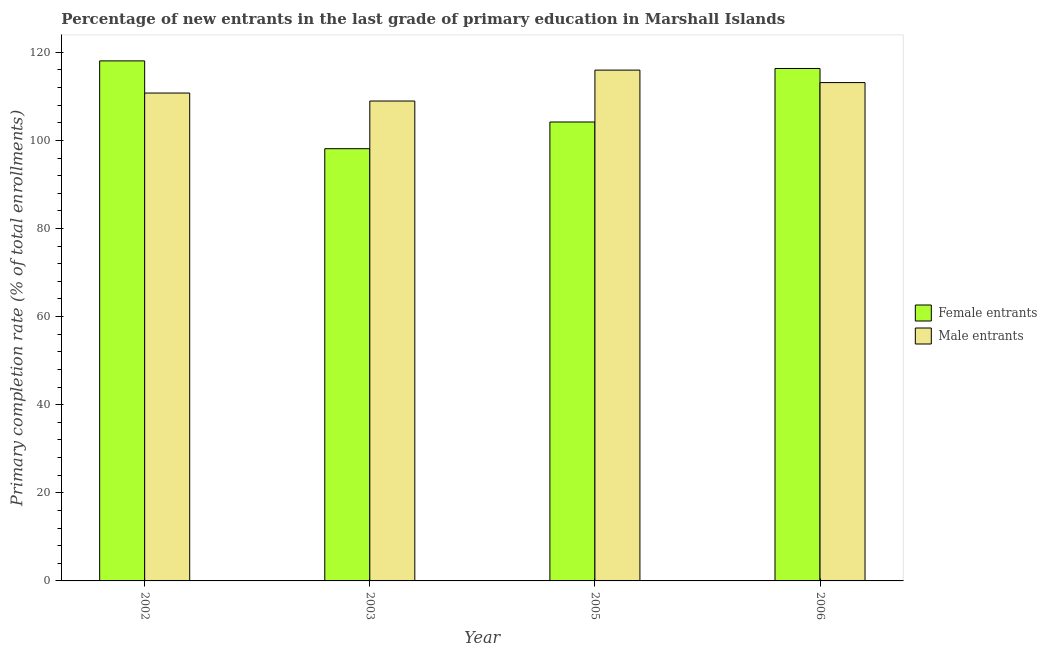How many groups of bars are there?
Provide a succinct answer. 4. Are the number of bars per tick equal to the number of legend labels?
Your answer should be very brief. Yes. Are the number of bars on each tick of the X-axis equal?
Give a very brief answer. Yes. How many bars are there on the 1st tick from the left?
Your response must be concise. 2. What is the label of the 3rd group of bars from the left?
Your response must be concise. 2005. In how many cases, is the number of bars for a given year not equal to the number of legend labels?
Make the answer very short. 0. What is the primary completion rate of male entrants in 2002?
Offer a very short reply. 110.76. Across all years, what is the maximum primary completion rate of male entrants?
Make the answer very short. 115.96. Across all years, what is the minimum primary completion rate of female entrants?
Provide a succinct answer. 98.12. In which year was the primary completion rate of male entrants maximum?
Offer a very short reply. 2005. What is the total primary completion rate of female entrants in the graph?
Offer a very short reply. 436.69. What is the difference between the primary completion rate of male entrants in 2005 and that in 2006?
Your response must be concise. 2.83. What is the difference between the primary completion rate of male entrants in 2003 and the primary completion rate of female entrants in 2002?
Your answer should be compact. -1.81. What is the average primary completion rate of male entrants per year?
Offer a terse response. 112.2. In the year 2003, what is the difference between the primary completion rate of male entrants and primary completion rate of female entrants?
Provide a short and direct response. 0. What is the ratio of the primary completion rate of female entrants in 2002 to that in 2006?
Offer a very short reply. 1.01. Is the difference between the primary completion rate of female entrants in 2003 and 2006 greater than the difference between the primary completion rate of male entrants in 2003 and 2006?
Provide a succinct answer. No. What is the difference between the highest and the second highest primary completion rate of female entrants?
Ensure brevity in your answer.  1.72. What is the difference between the highest and the lowest primary completion rate of male entrants?
Offer a terse response. 7.02. In how many years, is the primary completion rate of female entrants greater than the average primary completion rate of female entrants taken over all years?
Provide a short and direct response. 2. Is the sum of the primary completion rate of female entrants in 2003 and 2006 greater than the maximum primary completion rate of male entrants across all years?
Offer a terse response. Yes. What does the 2nd bar from the left in 2003 represents?
Your response must be concise. Male entrants. What does the 1st bar from the right in 2003 represents?
Offer a terse response. Male entrants. Are all the bars in the graph horizontal?
Keep it short and to the point. No. How many years are there in the graph?
Give a very brief answer. 4. Are the values on the major ticks of Y-axis written in scientific E-notation?
Ensure brevity in your answer.  No. Does the graph contain any zero values?
Give a very brief answer. No. Where does the legend appear in the graph?
Make the answer very short. Center right. How many legend labels are there?
Ensure brevity in your answer.  2. What is the title of the graph?
Keep it short and to the point. Percentage of new entrants in the last grade of primary education in Marshall Islands. Does "Commercial service imports" appear as one of the legend labels in the graph?
Make the answer very short. No. What is the label or title of the X-axis?
Provide a short and direct response. Year. What is the label or title of the Y-axis?
Offer a very short reply. Primary completion rate (% of total enrollments). What is the Primary completion rate (% of total enrollments) of Female entrants in 2002?
Give a very brief answer. 118.06. What is the Primary completion rate (% of total enrollments) in Male entrants in 2002?
Your response must be concise. 110.76. What is the Primary completion rate (% of total enrollments) of Female entrants in 2003?
Provide a short and direct response. 98.12. What is the Primary completion rate (% of total enrollments) in Male entrants in 2003?
Ensure brevity in your answer.  108.94. What is the Primary completion rate (% of total enrollments) in Female entrants in 2005?
Provide a succinct answer. 104.18. What is the Primary completion rate (% of total enrollments) in Male entrants in 2005?
Your answer should be very brief. 115.96. What is the Primary completion rate (% of total enrollments) in Female entrants in 2006?
Make the answer very short. 116.33. What is the Primary completion rate (% of total enrollments) of Male entrants in 2006?
Provide a succinct answer. 113.13. Across all years, what is the maximum Primary completion rate (% of total enrollments) of Female entrants?
Your response must be concise. 118.06. Across all years, what is the maximum Primary completion rate (% of total enrollments) in Male entrants?
Give a very brief answer. 115.96. Across all years, what is the minimum Primary completion rate (% of total enrollments) of Female entrants?
Offer a terse response. 98.12. Across all years, what is the minimum Primary completion rate (% of total enrollments) in Male entrants?
Give a very brief answer. 108.94. What is the total Primary completion rate (% of total enrollments) of Female entrants in the graph?
Your response must be concise. 436.69. What is the total Primary completion rate (% of total enrollments) in Male entrants in the graph?
Make the answer very short. 448.79. What is the difference between the Primary completion rate (% of total enrollments) in Female entrants in 2002 and that in 2003?
Provide a succinct answer. 19.94. What is the difference between the Primary completion rate (% of total enrollments) of Male entrants in 2002 and that in 2003?
Your answer should be very brief. 1.81. What is the difference between the Primary completion rate (% of total enrollments) in Female entrants in 2002 and that in 2005?
Provide a short and direct response. 13.87. What is the difference between the Primary completion rate (% of total enrollments) in Male entrants in 2002 and that in 2005?
Provide a short and direct response. -5.21. What is the difference between the Primary completion rate (% of total enrollments) of Female entrants in 2002 and that in 2006?
Provide a short and direct response. 1.72. What is the difference between the Primary completion rate (% of total enrollments) in Male entrants in 2002 and that in 2006?
Your answer should be compact. -2.37. What is the difference between the Primary completion rate (% of total enrollments) in Female entrants in 2003 and that in 2005?
Your answer should be compact. -6.06. What is the difference between the Primary completion rate (% of total enrollments) of Male entrants in 2003 and that in 2005?
Provide a succinct answer. -7.02. What is the difference between the Primary completion rate (% of total enrollments) of Female entrants in 2003 and that in 2006?
Your answer should be very brief. -18.21. What is the difference between the Primary completion rate (% of total enrollments) of Male entrants in 2003 and that in 2006?
Give a very brief answer. -4.18. What is the difference between the Primary completion rate (% of total enrollments) of Female entrants in 2005 and that in 2006?
Your answer should be compact. -12.15. What is the difference between the Primary completion rate (% of total enrollments) in Male entrants in 2005 and that in 2006?
Make the answer very short. 2.83. What is the difference between the Primary completion rate (% of total enrollments) in Female entrants in 2002 and the Primary completion rate (% of total enrollments) in Male entrants in 2003?
Provide a short and direct response. 9.11. What is the difference between the Primary completion rate (% of total enrollments) in Female entrants in 2002 and the Primary completion rate (% of total enrollments) in Male entrants in 2005?
Keep it short and to the point. 2.09. What is the difference between the Primary completion rate (% of total enrollments) of Female entrants in 2002 and the Primary completion rate (% of total enrollments) of Male entrants in 2006?
Offer a very short reply. 4.93. What is the difference between the Primary completion rate (% of total enrollments) of Female entrants in 2003 and the Primary completion rate (% of total enrollments) of Male entrants in 2005?
Your answer should be compact. -17.84. What is the difference between the Primary completion rate (% of total enrollments) in Female entrants in 2003 and the Primary completion rate (% of total enrollments) in Male entrants in 2006?
Your answer should be very brief. -15.01. What is the difference between the Primary completion rate (% of total enrollments) in Female entrants in 2005 and the Primary completion rate (% of total enrollments) in Male entrants in 2006?
Ensure brevity in your answer.  -8.94. What is the average Primary completion rate (% of total enrollments) in Female entrants per year?
Keep it short and to the point. 109.17. What is the average Primary completion rate (% of total enrollments) in Male entrants per year?
Offer a terse response. 112.2. In the year 2002, what is the difference between the Primary completion rate (% of total enrollments) in Female entrants and Primary completion rate (% of total enrollments) in Male entrants?
Your answer should be compact. 7.3. In the year 2003, what is the difference between the Primary completion rate (% of total enrollments) of Female entrants and Primary completion rate (% of total enrollments) of Male entrants?
Keep it short and to the point. -10.82. In the year 2005, what is the difference between the Primary completion rate (% of total enrollments) of Female entrants and Primary completion rate (% of total enrollments) of Male entrants?
Make the answer very short. -11.78. In the year 2006, what is the difference between the Primary completion rate (% of total enrollments) of Female entrants and Primary completion rate (% of total enrollments) of Male entrants?
Give a very brief answer. 3.2. What is the ratio of the Primary completion rate (% of total enrollments) of Female entrants in 2002 to that in 2003?
Ensure brevity in your answer.  1.2. What is the ratio of the Primary completion rate (% of total enrollments) of Male entrants in 2002 to that in 2003?
Provide a succinct answer. 1.02. What is the ratio of the Primary completion rate (% of total enrollments) of Female entrants in 2002 to that in 2005?
Offer a terse response. 1.13. What is the ratio of the Primary completion rate (% of total enrollments) of Male entrants in 2002 to that in 2005?
Offer a very short reply. 0.96. What is the ratio of the Primary completion rate (% of total enrollments) in Female entrants in 2002 to that in 2006?
Ensure brevity in your answer.  1.01. What is the ratio of the Primary completion rate (% of total enrollments) of Female entrants in 2003 to that in 2005?
Offer a terse response. 0.94. What is the ratio of the Primary completion rate (% of total enrollments) of Male entrants in 2003 to that in 2005?
Your response must be concise. 0.94. What is the ratio of the Primary completion rate (% of total enrollments) in Female entrants in 2003 to that in 2006?
Your response must be concise. 0.84. What is the ratio of the Primary completion rate (% of total enrollments) in Male entrants in 2003 to that in 2006?
Offer a terse response. 0.96. What is the ratio of the Primary completion rate (% of total enrollments) in Female entrants in 2005 to that in 2006?
Keep it short and to the point. 0.9. What is the ratio of the Primary completion rate (% of total enrollments) in Male entrants in 2005 to that in 2006?
Provide a succinct answer. 1.03. What is the difference between the highest and the second highest Primary completion rate (% of total enrollments) of Female entrants?
Your answer should be compact. 1.72. What is the difference between the highest and the second highest Primary completion rate (% of total enrollments) in Male entrants?
Offer a very short reply. 2.83. What is the difference between the highest and the lowest Primary completion rate (% of total enrollments) in Female entrants?
Offer a terse response. 19.94. What is the difference between the highest and the lowest Primary completion rate (% of total enrollments) of Male entrants?
Keep it short and to the point. 7.02. 